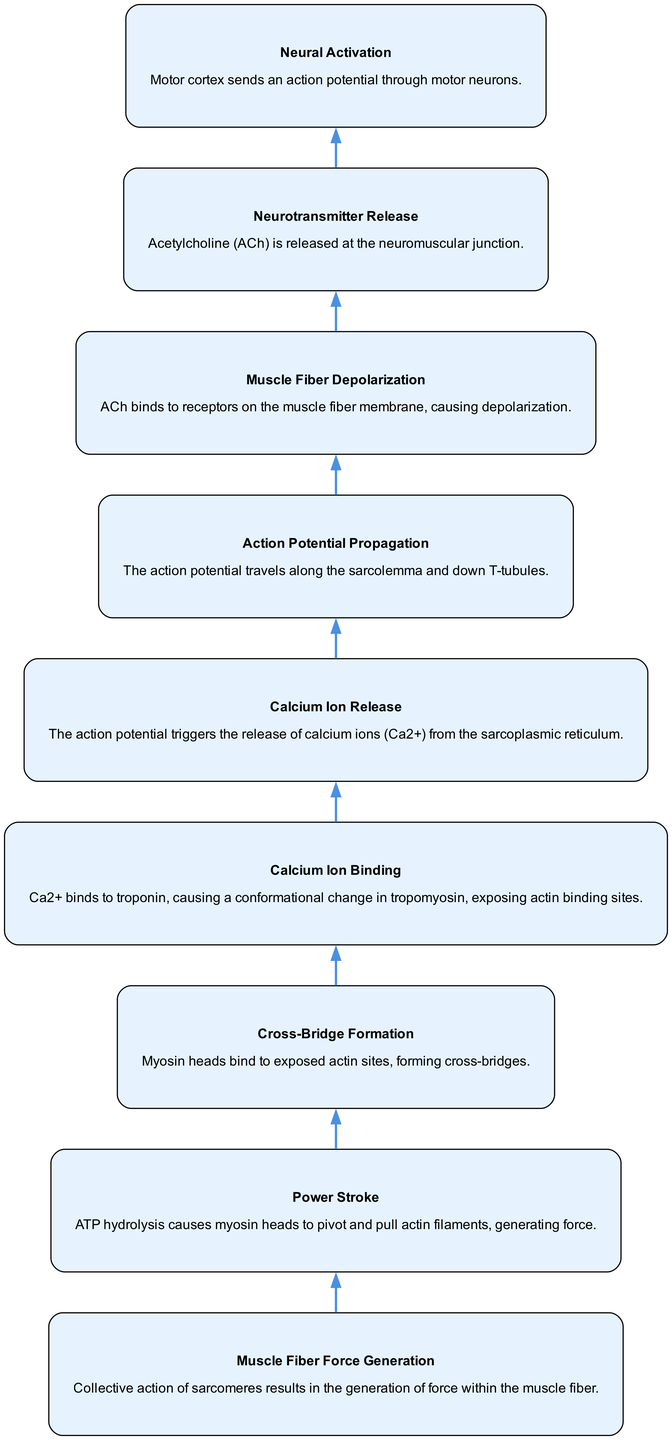What is the first step in the flow? The first step in the flow is "Neural Activation," which is indicated as the bottommost part of the diagram. It highlights where the process begins.
Answer: Neural Activation How many nodes are present in the diagram? The diagram contains a total of 9 nodes, representing each significant step in the muscle contraction process, as listed in the data provided.
Answer: 9 What binds to the receptors on the muscle fiber membrane? The diagram specifies that Acetylcholine (ACh) binds to the receptors on the muscle fiber membrane during the "Neurotransmitter Release" step.
Answer: Acetylcholine What triggers the release of calcium ions? The action potential, which propagates through the muscle fiber, is indicated to trigger the release of calcium ions from the sarcoplasmic reticulum as shown in the "Calcium Ion Release" step.
Answer: The action potential What happens after calcium ions bind to troponin? After calcium ions bind to troponin, a conformational change in tropomyosin occurs, which exposes actin binding sites, as described in the "Calcium Ion Binding" step.
Answer: Exposing actin binding sites How does a power stroke generate force? The "Power Stroke" step illustrates that ATP hydrolysis causes myosin heads to pivot and pull actin filaments, collectively resulting in the generation of force within the muscle fiber.
Answer: Myosin heads pivot and pull actin filaments Which step leads directly to muscle fiber force generation? The "Cross-Bridge Formation" directly leads to "Muscle Fiber Force Generation," as the formation of cross-bridges between myosin and actin is essential for generating force.
Answer: Cross-Bridge Formation What is the last process before muscle fiber force generation? The last process prior to muscle fiber force generation is "Power Stroke," which is responsible for utilizing the energy from ATP hydrolysis to create muscle movement.
Answer: Power Stroke 